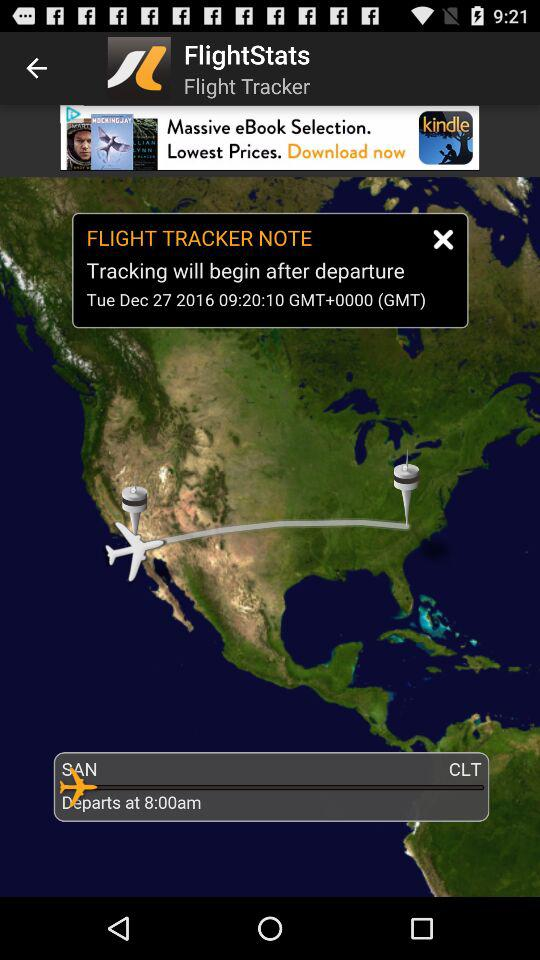What is the departure time?
Answer the question using a single word or phrase. 8:00am 